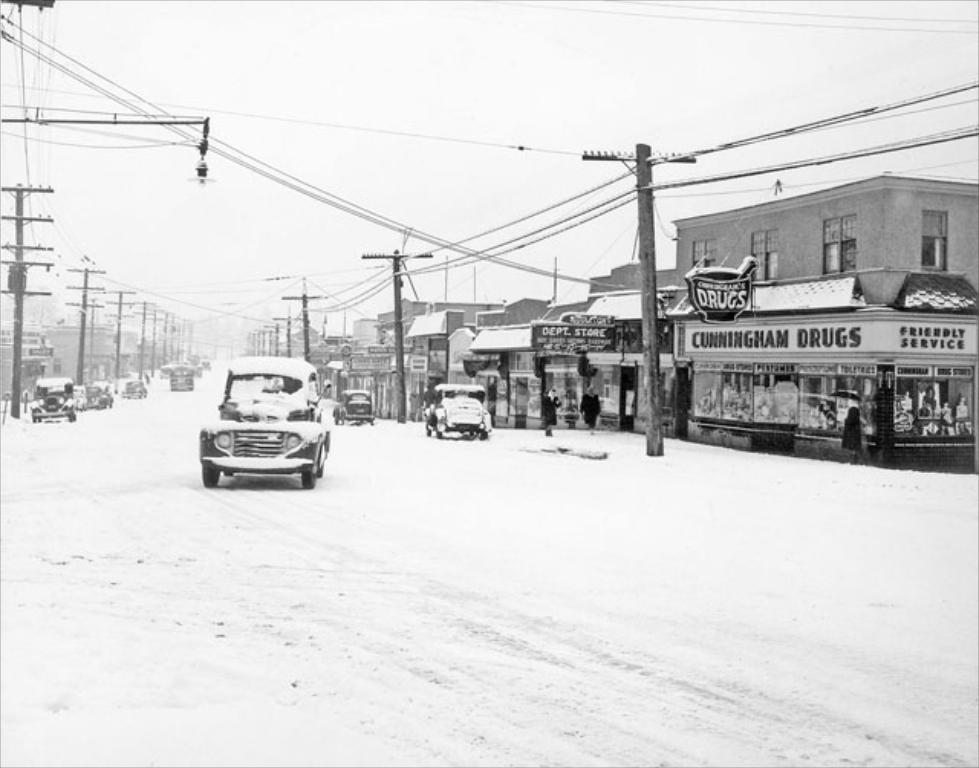In one or two sentences, can you explain what this image depicts? This is a black and white image , where there are vehicles on the road, there are poles, buildings, and in the background there is sky. 